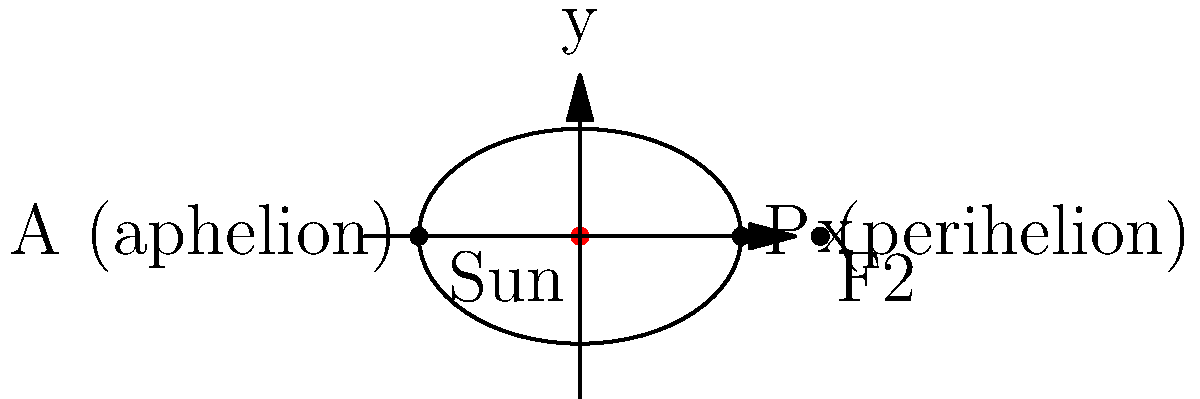As a museum curator planning an exhibit on historical astronomical observations, you need to accurately represent the orbit of Halley's Comet. Given the diagram of an elliptical orbit, identify the eccentricity of the comet's orbit and explain its significance in determining the comet's closest and farthest distances from the Sun. To solve this problem, let's follow these steps:

1. Understand the elliptical orbit:
   - The Sun is located at one of the foci (the red dot at the origin).
   - The other focus is labeled F2.
   - The semi-major axis (a) is half the longest diameter of the ellipse.
   - The semi-minor axis (b) is half the shortest diameter of the ellipse.

2. Calculate the eccentricity:
   - Eccentricity (e) is defined as the ratio of the distance between the foci to the length of the major axis.
   - It can be calculated using the formula: $e = \frac{c}{a}$, where c is the distance from the center to a focus.
   - From the diagram, we can see that $a = 3$ and $b = 2$.
   - We can calculate c using the Pythagorean theorem: $c^2 = a^2 - b^2$
   - $c = \sqrt{3^2 - 2^2} = \sqrt{5} \approx 2.236$
   - Therefore, $e = \frac{\sqrt{5}}{3} \approx 0.745$

3. Understand the significance of eccentricity:
   - Eccentricity determines the shape of the orbit and how much it deviates from a perfect circle.
   - It ranges from 0 (perfect circle) to 1 (parabola).
   - The higher the eccentricity, the more elongated the ellipse.

4. Relate eccentricity to the comet's distance from the Sun:
   - Perihelion (P): closest point to the Sun, given by $r_p = a(1-e)$
   - Aphelion (A): farthest point from the Sun, given by $r_a = a(1+e)$
   - The difference between these distances increases with higher eccentricity.

5. Calculate perihelion and aphelion distances:
   - $r_p = 3(1-0.745) = 0.765$ astronomical units (AU)
   - $r_a = 3(1+0.745) = 5.235$ AU

The eccentricity of approximately 0.745 indicates that Halley's Comet has a highly elliptical orbit, causing significant variation in its distance from the Sun throughout its orbit. This affects the comet's visibility, speed, and temperature as it travels through the solar system.
Answer: Eccentricity ≈ 0.745; determines orbit shape and Sun distance variation 